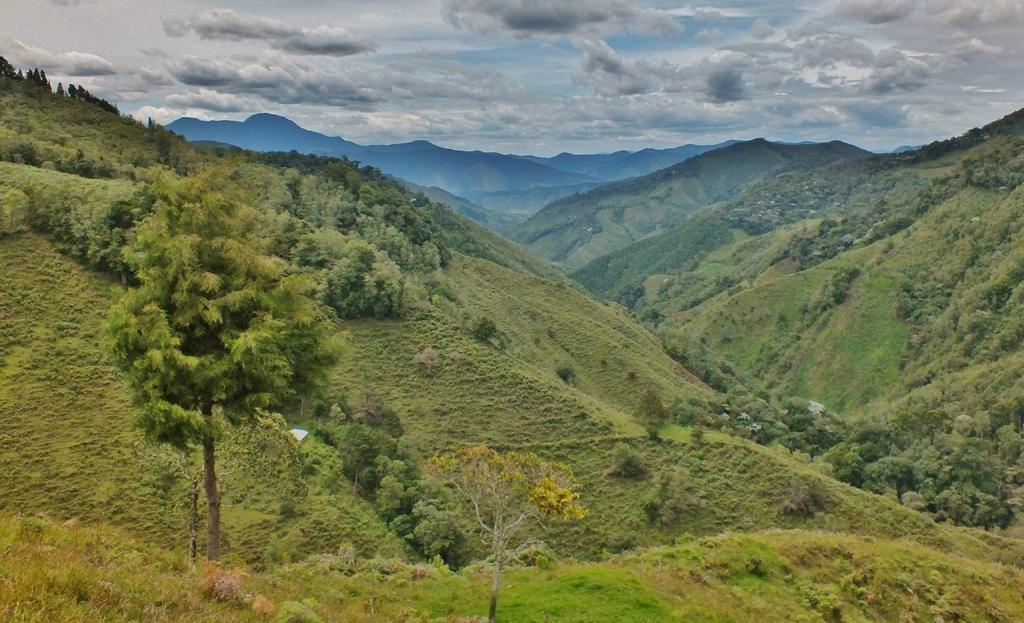What type of vegetation can be seen in the image? There are trees in the image. What color are the trees in the image? The trees are green in color. What is visible in the background of the image? The sky is visible in the background of the image. What colors can be seen in the sky in the image? The sky is blue and white in color. Can you tell me how many potatoes are buried under the trees in the image? There are no potatoes present in the image; it only features trees and the sky. What type of power source is visible in the image? There is no power source visible in the image; it only features trees and the sky. 